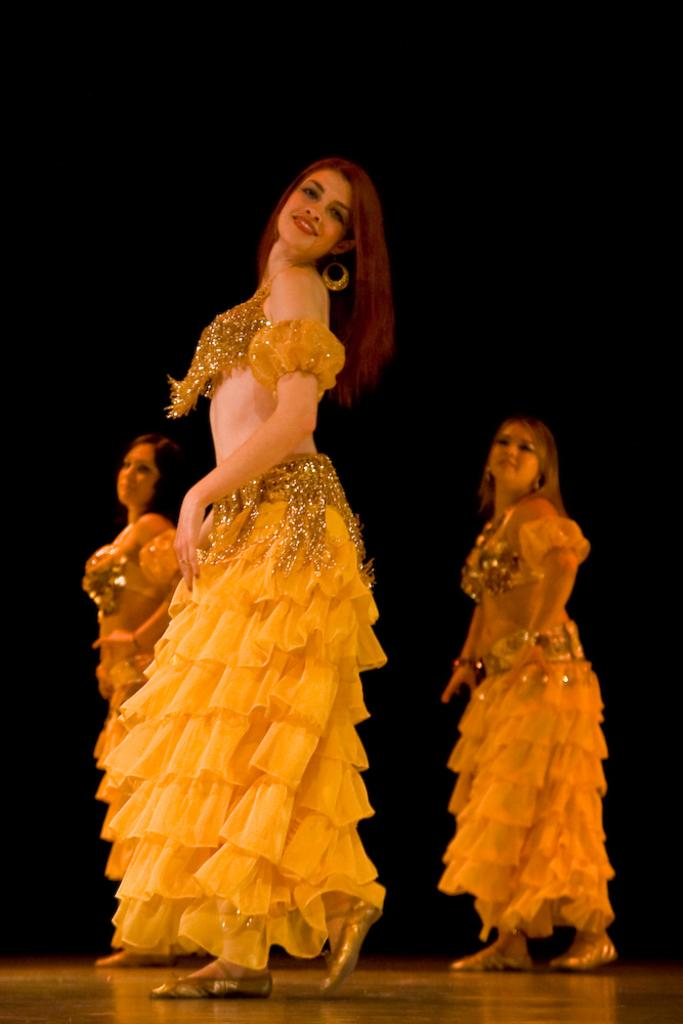How many people are in the image? There are three persons in the image. What are the persons doing in the image? The persons are dancing on the floor. Can you describe the background of the image? The background of the image is dark. What type of rose can be seen in the image? There is no rose present in the image. What is the name of the nation depicted in the image? There is no nation depicted in the image; it features three persons dancing on the floor with a dark background. 